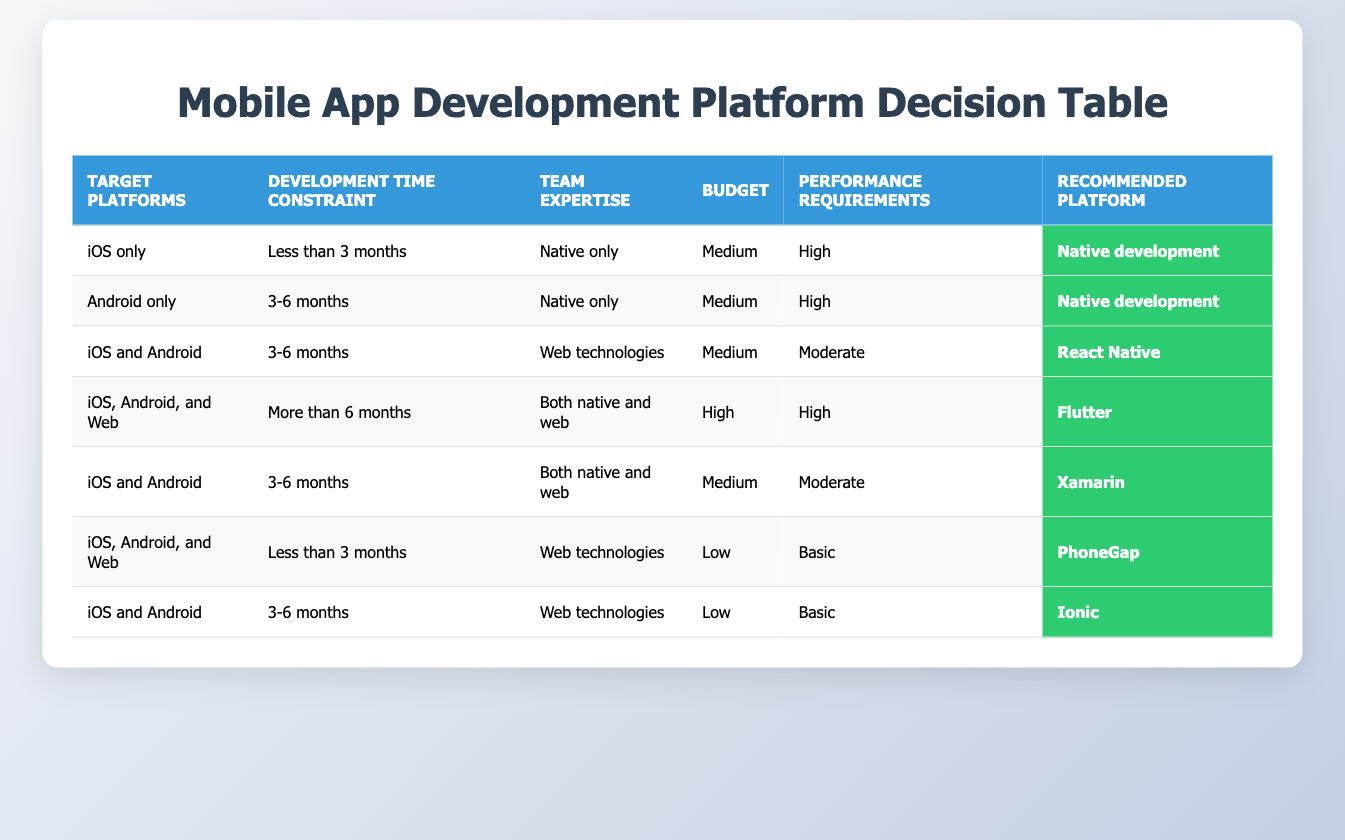What is the recommended platform for iOS only with less than 3 months of development time? The row that meets the criteria indicates "iOS only" for the target platform and "Less than 3 months" for the development time. This row states that the recommended platform is "Native development."
Answer: Native development What budget is required for using PhoneGap? The row for PhoneGap shows a budget categorized as "Low." Therefore, the budget required to use PhoneGap is low.
Answer: Low How many different platforms recommend the use of React Native? Looking at the table, React Native is recommended for one specific scenario: "iOS and Android" with a development time of "3-6 months", "Web technologies" for team expertise, "Medium" budget, and "Moderate" performance requirements. Thus, it is recommended in 1 case.
Answer: 1 Is Flutter recommended for scenarios with high performance requirements? The row mapping to Flutter has "High" for performance requirements, "High" budget, and mentions that it is for a combination of "iOS, Android, and Web" with a development time of "More than 6 months." This supports that Flutter is recommended for high performance requirements.
Answer: Yes How does the performance requirement differ between PhoneGap and Ionic when targeting both iOS and Android? PhoneGap requires "Basic" performance and is recommended for the scenario with "iOS, Android, and Web" and "Less than 3 months" of development time. In contrast, Ionic also targets "iOS and Android" but requires "Basic" performance with "3-6 months" development time. They have the same performance requirement, but the scenarios differ.
Answer: They are the same What is the recommended platform for a high budget and more than 6 months of development targeting both native and web? We look for a row where the budget is "High", the development time is "More than 6 months", and the team has expertise in "Both native and web." This corresponds to Flutter. So the recommended platform for this situation is Flutter.
Answer: Flutter Which platforms are recommended when using web technologies as team expertise with a low budget? Two rows apply: one leads to PhoneGap (for "iOS, Android, and Web") with "Less than 3 months" and "Basic" performance, and the other leads to Ionic (for "iOS and Android") with "3-6 months" and "Basic" performance. Therefore, the recommended platforms are PhoneGap and Ionic.
Answer: PhoneGap, Ionic Which development platform is recommended if the team can only handle web technologies and a budget is medium? The criteria specify the need for "Web technologies" as team expertise and a "Medium" budget, while the development time can be "3-6 months". The matching row indicates that React Native is the recommended platform.
Answer: React Native How many different recommended platforms require a development time of 3-6 months? We go through the table and identify those rows where the development time is "3-6 months." The platforms recommended in these scenarios are Native development (1), React Native (1), Xamarin (1), and Ionic (1). This makes a total of 4 different platforms.
Answer: 4 